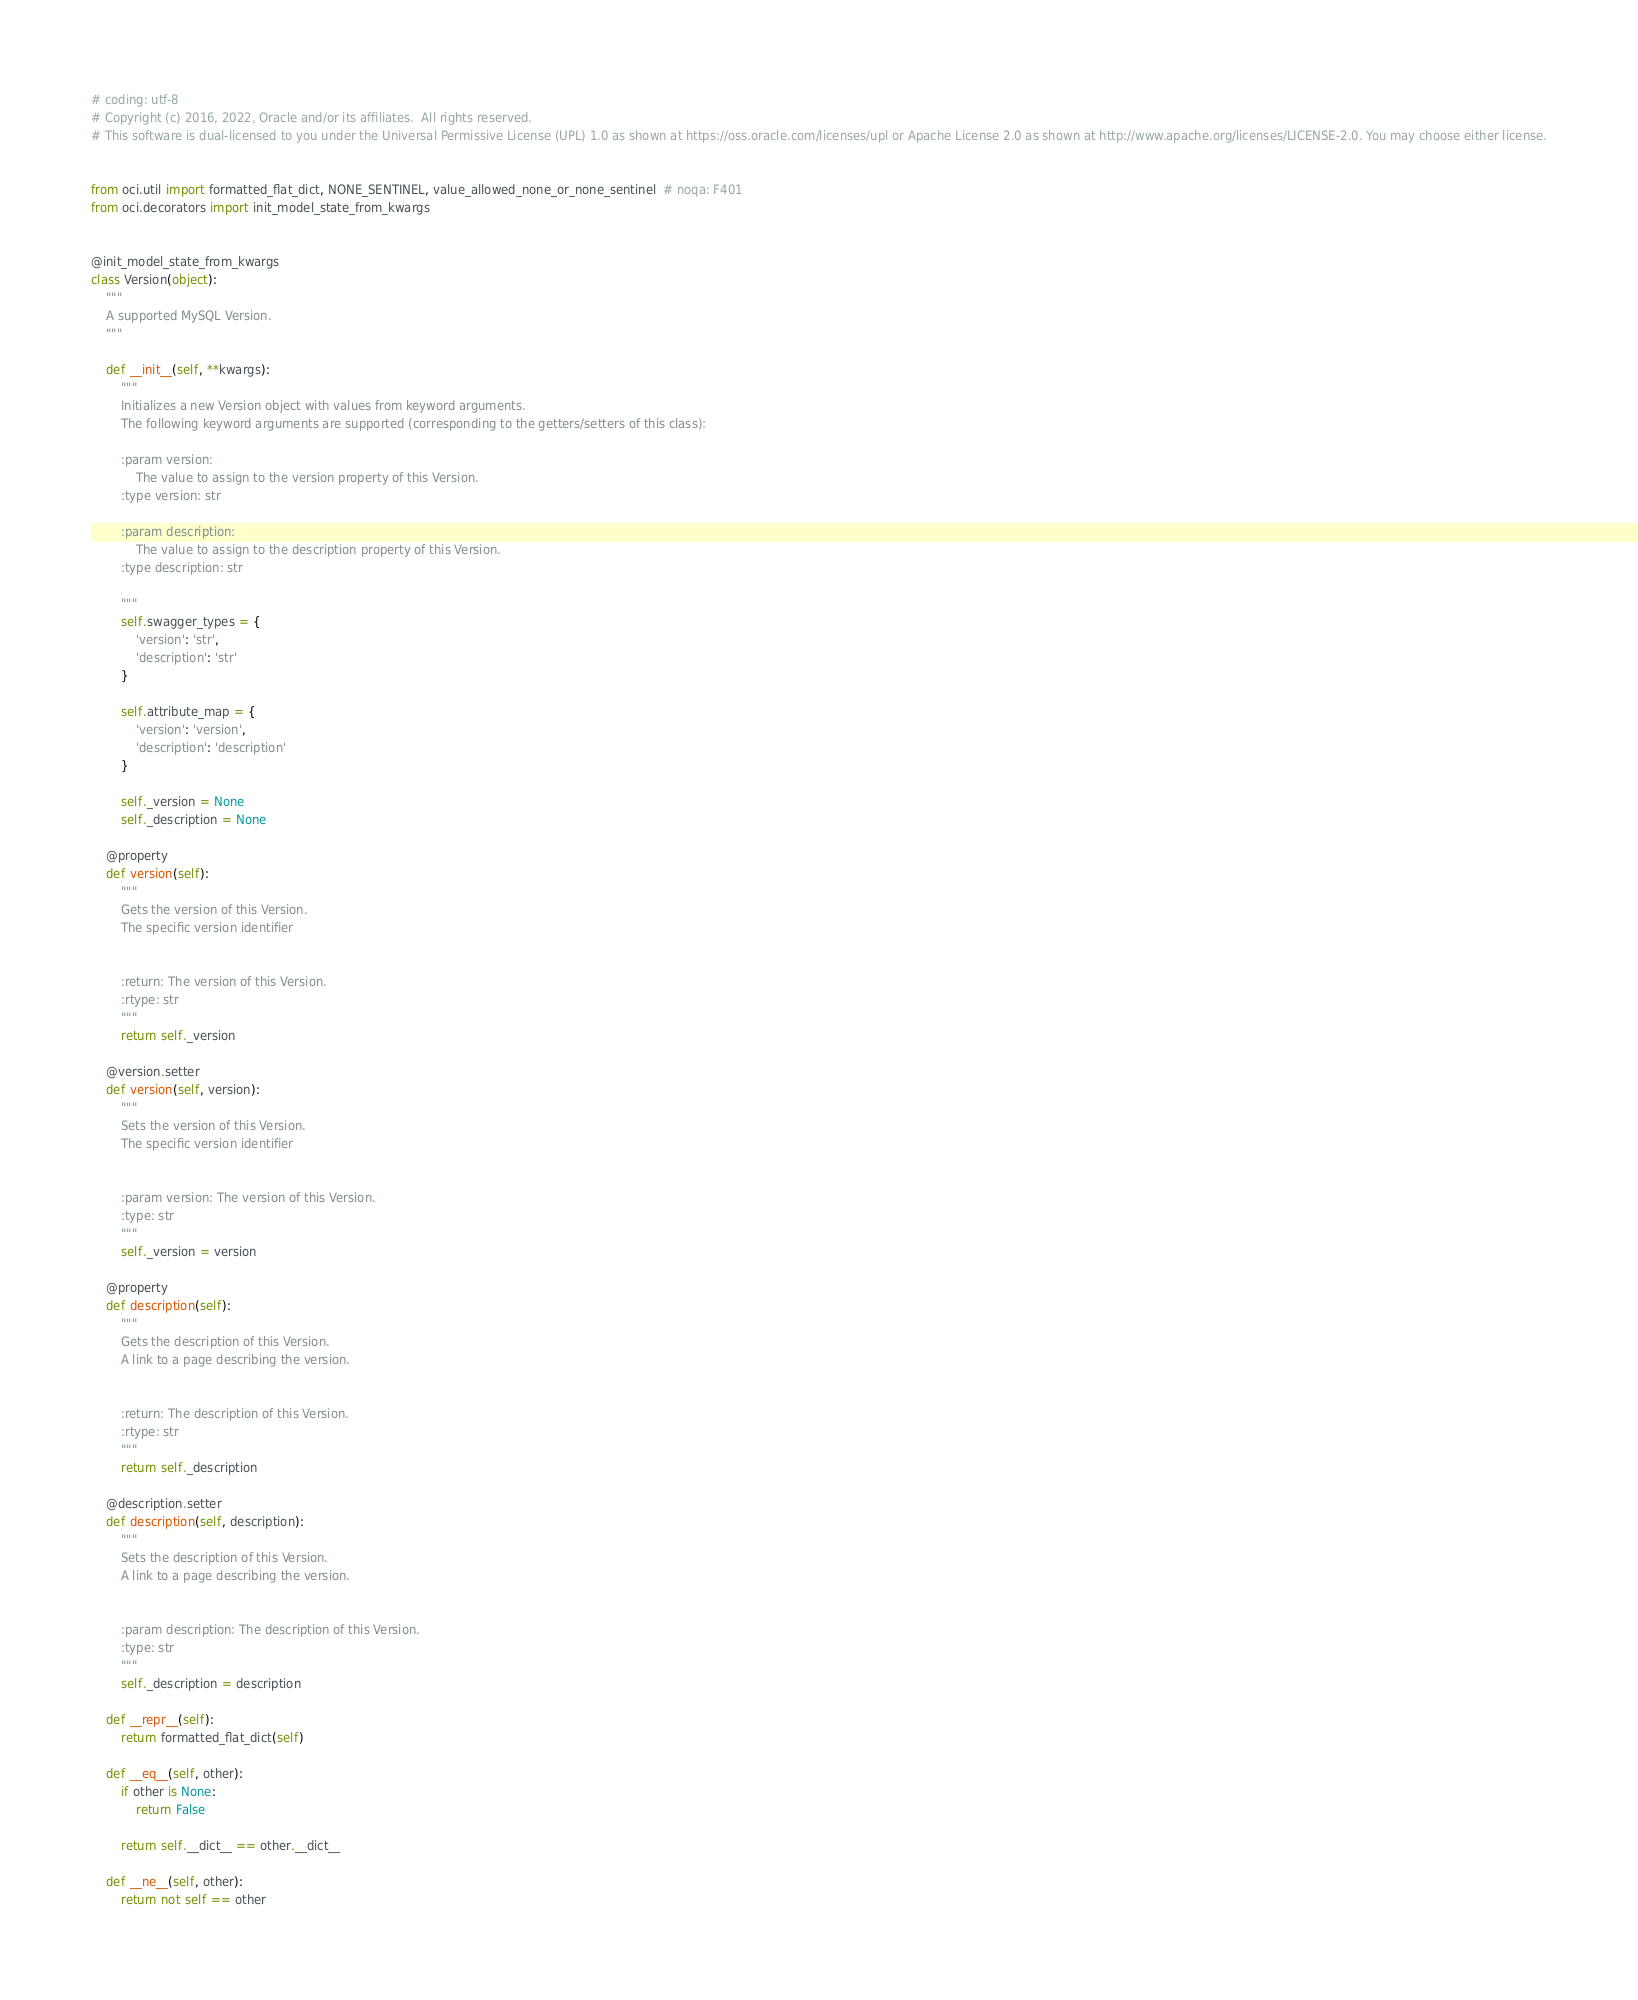Convert code to text. <code><loc_0><loc_0><loc_500><loc_500><_Python_># coding: utf-8
# Copyright (c) 2016, 2022, Oracle and/or its affiliates.  All rights reserved.
# This software is dual-licensed to you under the Universal Permissive License (UPL) 1.0 as shown at https://oss.oracle.com/licenses/upl or Apache License 2.0 as shown at http://www.apache.org/licenses/LICENSE-2.0. You may choose either license.


from oci.util import formatted_flat_dict, NONE_SENTINEL, value_allowed_none_or_none_sentinel  # noqa: F401
from oci.decorators import init_model_state_from_kwargs


@init_model_state_from_kwargs
class Version(object):
    """
    A supported MySQL Version.
    """

    def __init__(self, **kwargs):
        """
        Initializes a new Version object with values from keyword arguments.
        The following keyword arguments are supported (corresponding to the getters/setters of this class):

        :param version:
            The value to assign to the version property of this Version.
        :type version: str

        :param description:
            The value to assign to the description property of this Version.
        :type description: str

        """
        self.swagger_types = {
            'version': 'str',
            'description': 'str'
        }

        self.attribute_map = {
            'version': 'version',
            'description': 'description'
        }

        self._version = None
        self._description = None

    @property
    def version(self):
        """
        Gets the version of this Version.
        The specific version identifier


        :return: The version of this Version.
        :rtype: str
        """
        return self._version

    @version.setter
    def version(self, version):
        """
        Sets the version of this Version.
        The specific version identifier


        :param version: The version of this Version.
        :type: str
        """
        self._version = version

    @property
    def description(self):
        """
        Gets the description of this Version.
        A link to a page describing the version.


        :return: The description of this Version.
        :rtype: str
        """
        return self._description

    @description.setter
    def description(self, description):
        """
        Sets the description of this Version.
        A link to a page describing the version.


        :param description: The description of this Version.
        :type: str
        """
        self._description = description

    def __repr__(self):
        return formatted_flat_dict(self)

    def __eq__(self, other):
        if other is None:
            return False

        return self.__dict__ == other.__dict__

    def __ne__(self, other):
        return not self == other
</code> 